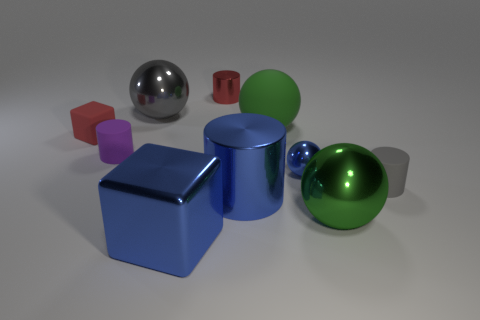Subtract all shiny balls. How many balls are left? 1 Subtract all purple balls. Subtract all blue cubes. How many balls are left? 4 Subtract all cylinders. How many objects are left? 6 Add 9 small gray cylinders. How many small gray cylinders exist? 10 Subtract 1 red cylinders. How many objects are left? 9 Subtract all small purple metal objects. Subtract all matte spheres. How many objects are left? 9 Add 8 big green rubber spheres. How many big green rubber spheres are left? 9 